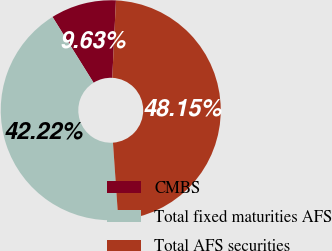Convert chart. <chart><loc_0><loc_0><loc_500><loc_500><pie_chart><fcel>CMBS<fcel>Total fixed maturities AFS<fcel>Total AFS securities<nl><fcel>9.63%<fcel>42.22%<fcel>48.15%<nl></chart> 